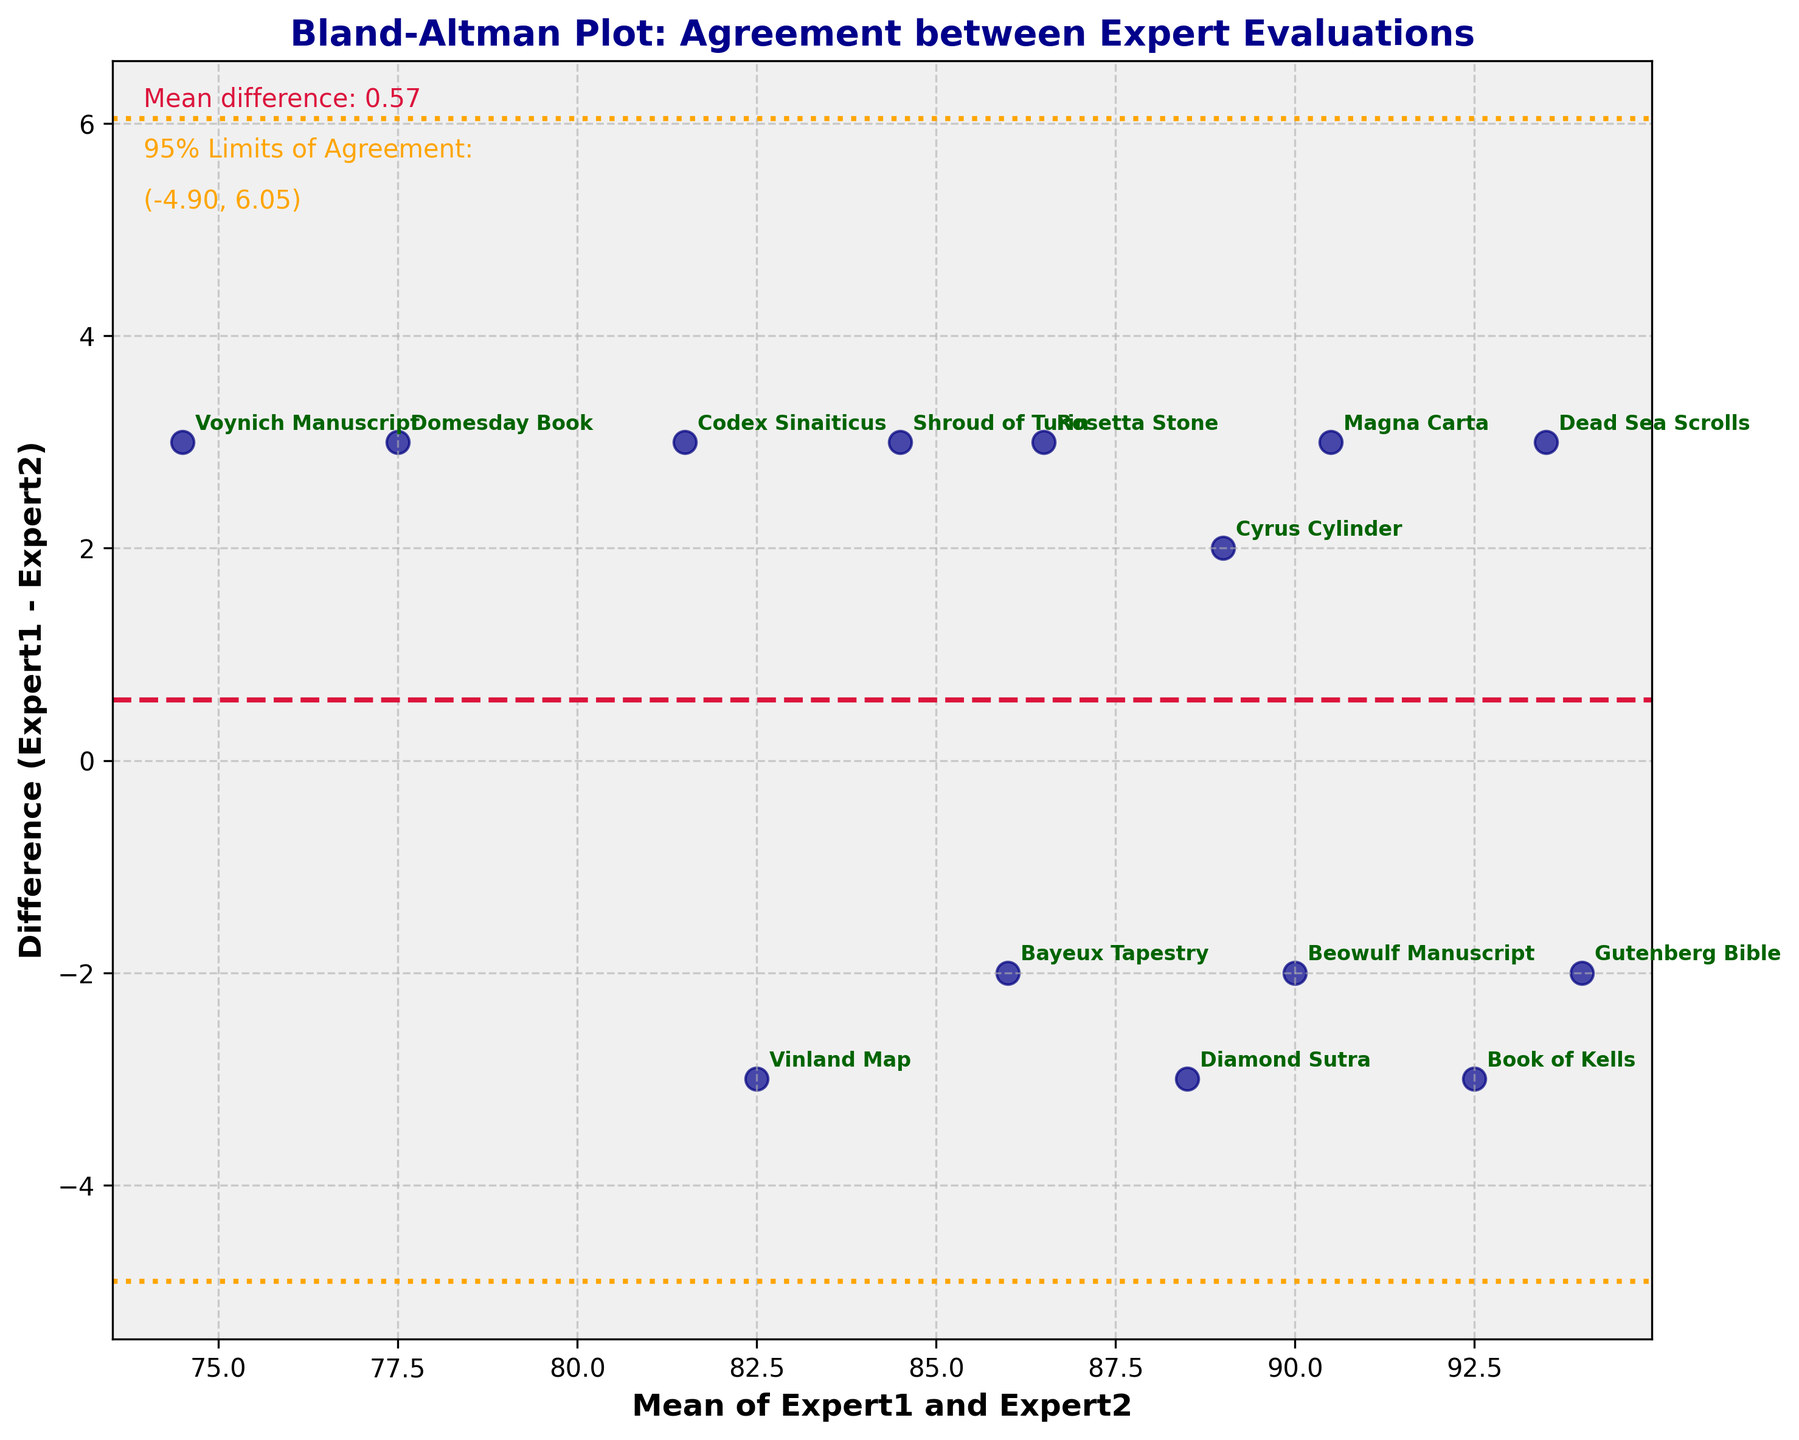What does the Bland-Altman plot aim to show? Explanation: The Bland-Altman plot is used to compare two different evaluations by plotting the differences between the evaluations against their mean. It helps to visualize the agreement between the two methods.
Answer: Agreement between Expert1 and Expert2 What are the labels of the axes? Explanation: The x-axis is labeled "Mean of Expert1 and Expert2," and the y-axis is labeled "Difference (Expert1 - Expert2)." These labels are used to show what each axis represents in the plot.
Answer: Mean of Expert1 and Expert2, Difference (Expert1 - Expert2) What does the crimson (red) dashed line in the plot represent? Explanation: The crimson dashed line represents the mean difference between the two expert evaluations. It helps to identify the bias between Expert1 and Expert2's assessments.
Answer: Mean difference What are the orange dotted lines on the plot? Explanation: The orange dotted lines represent the 95% limits of agreement, which are calculated as the mean difference ± 1.96 times the standard deviation of the differences. These lines indicate the range within which most differences between evaluations should fall.
Answer: 95% limits of agreement What do the dots on the plot represent? Explanation: Each dot represents a historical artifact, and its position on the plot corresponds to the mean of evaluations by Expert1 and Expert2 on the x-axis and the difference between these evaluations on the y-axis.
Answer: Historical artifacts How many artifacts have a positive difference (Expert1 > Expert2)? Explanation: By counting the data points above the y=0 line (positive difference), we can determine the number of artifacts where Expert1's evaluation is higher than Expert2's.
Answer: 6 Which historical artifact has the largest positive difference? Explanation: By examining the dots above the y=0 line and noting their labels, we find that the "Book of Kells" has the largest positive difference.
Answer: Book of Kells Which artifact shows the smallest difference in evaluations between Expert1 and Expert2? Explanation: The artifact closest to the y=0 line represents the smallest difference. By checking the labeled points near this line, we identify the "Shroud of Turin."
Answer: Shroud of Turin What is the mean value and difference for the "Vinland Map"? Explanation: Locate the point labeled "Vinland Map" and read its coordinates from the plot. The x-coordinate is the mean, and the y-coordinate is the difference.
Answer: Mean = 82.5, Difference = -3 How many artifacts fall outside the 95% limits of agreement? Explanation: Count the number of data points that lie outside the orange dotted lines representing the 95% limits.
Answer: 0 